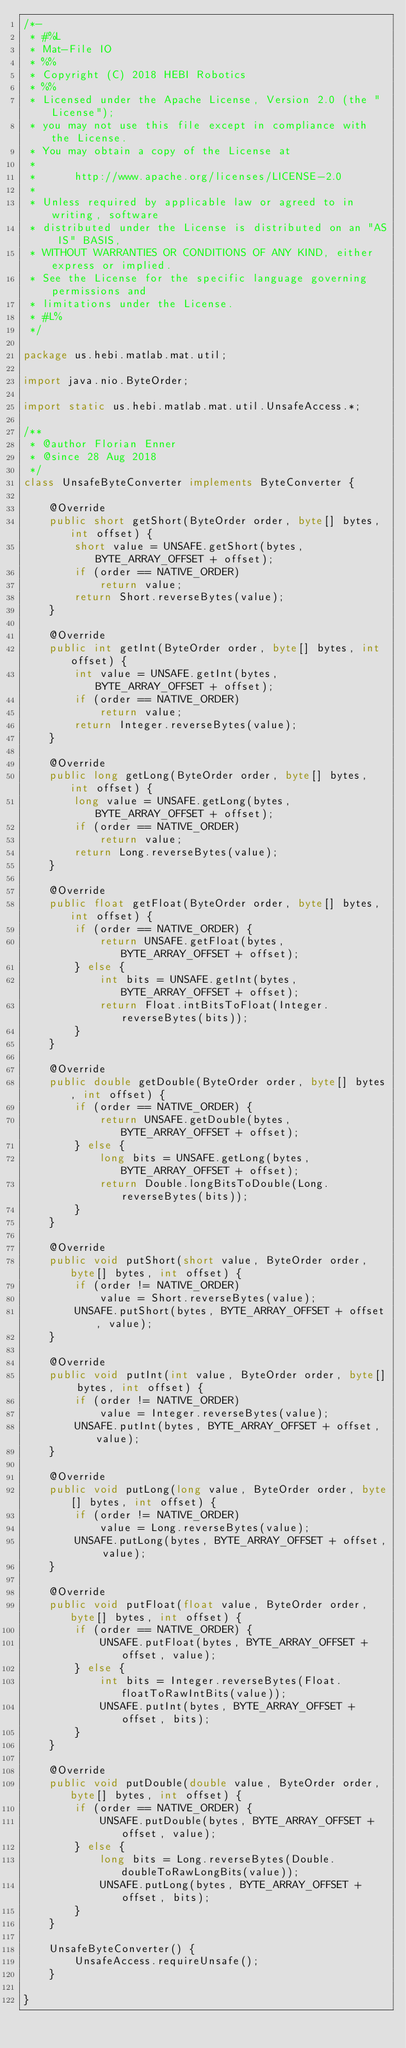<code> <loc_0><loc_0><loc_500><loc_500><_Java_>/*-
 * #%L
 * Mat-File IO
 * %%
 * Copyright (C) 2018 HEBI Robotics
 * %%
 * Licensed under the Apache License, Version 2.0 (the "License");
 * you may not use this file except in compliance with the License.
 * You may obtain a copy of the License at
 * 
 *      http://www.apache.org/licenses/LICENSE-2.0
 * 
 * Unless required by applicable law or agreed to in writing, software
 * distributed under the License is distributed on an "AS IS" BASIS,
 * WITHOUT WARRANTIES OR CONDITIONS OF ANY KIND, either express or implied.
 * See the License for the specific language governing permissions and
 * limitations under the License.
 * #L%
 */

package us.hebi.matlab.mat.util;

import java.nio.ByteOrder;

import static us.hebi.matlab.mat.util.UnsafeAccess.*;

/**
 * @author Florian Enner
 * @since 28 Aug 2018
 */
class UnsafeByteConverter implements ByteConverter {

    @Override
    public short getShort(ByteOrder order, byte[] bytes, int offset) {
        short value = UNSAFE.getShort(bytes, BYTE_ARRAY_OFFSET + offset);
        if (order == NATIVE_ORDER)
            return value;
        return Short.reverseBytes(value);
    }

    @Override
    public int getInt(ByteOrder order, byte[] bytes, int offset) {
        int value = UNSAFE.getInt(bytes, BYTE_ARRAY_OFFSET + offset);
        if (order == NATIVE_ORDER)
            return value;
        return Integer.reverseBytes(value);
    }

    @Override
    public long getLong(ByteOrder order, byte[] bytes, int offset) {
        long value = UNSAFE.getLong(bytes, BYTE_ARRAY_OFFSET + offset);
        if (order == NATIVE_ORDER)
            return value;
        return Long.reverseBytes(value);
    }

    @Override
    public float getFloat(ByteOrder order, byte[] bytes, int offset) {
        if (order == NATIVE_ORDER) {
            return UNSAFE.getFloat(bytes, BYTE_ARRAY_OFFSET + offset);
        } else {
            int bits = UNSAFE.getInt(bytes, BYTE_ARRAY_OFFSET + offset);
            return Float.intBitsToFloat(Integer.reverseBytes(bits));
        }
    }

    @Override
    public double getDouble(ByteOrder order, byte[] bytes, int offset) {
        if (order == NATIVE_ORDER) {
            return UNSAFE.getDouble(bytes, BYTE_ARRAY_OFFSET + offset);
        } else {
            long bits = UNSAFE.getLong(bytes, BYTE_ARRAY_OFFSET + offset);
            return Double.longBitsToDouble(Long.reverseBytes(bits));
        }
    }

    @Override
    public void putShort(short value, ByteOrder order, byte[] bytes, int offset) {
        if (order != NATIVE_ORDER)
            value = Short.reverseBytes(value);
        UNSAFE.putShort(bytes, BYTE_ARRAY_OFFSET + offset, value);
    }

    @Override
    public void putInt(int value, ByteOrder order, byte[] bytes, int offset) {
        if (order != NATIVE_ORDER)
            value = Integer.reverseBytes(value);
        UNSAFE.putInt(bytes, BYTE_ARRAY_OFFSET + offset, value);
    }

    @Override
    public void putLong(long value, ByteOrder order, byte[] bytes, int offset) {
        if (order != NATIVE_ORDER)
            value = Long.reverseBytes(value);
        UNSAFE.putLong(bytes, BYTE_ARRAY_OFFSET + offset, value);
    }

    @Override
    public void putFloat(float value, ByteOrder order, byte[] bytes, int offset) {
        if (order == NATIVE_ORDER) {
            UNSAFE.putFloat(bytes, BYTE_ARRAY_OFFSET + offset, value);
        } else {
            int bits = Integer.reverseBytes(Float.floatToRawIntBits(value));
            UNSAFE.putInt(bytes, BYTE_ARRAY_OFFSET + offset, bits);
        }
    }

    @Override
    public void putDouble(double value, ByteOrder order, byte[] bytes, int offset) {
        if (order == NATIVE_ORDER) {
            UNSAFE.putDouble(bytes, BYTE_ARRAY_OFFSET + offset, value);
        } else {
            long bits = Long.reverseBytes(Double.doubleToRawLongBits(value));
            UNSAFE.putLong(bytes, BYTE_ARRAY_OFFSET + offset, bits);
        }
    }

    UnsafeByteConverter() {
        UnsafeAccess.requireUnsafe();
    }

}
</code> 